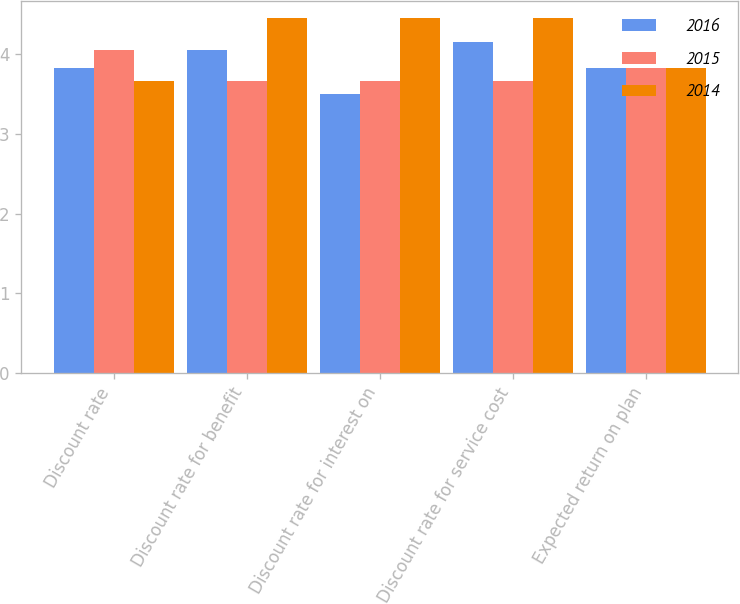Convert chart to OTSL. <chart><loc_0><loc_0><loc_500><loc_500><stacked_bar_chart><ecel><fcel>Discount rate<fcel>Discount rate for benefit<fcel>Discount rate for interest on<fcel>Discount rate for service cost<fcel>Expected return on plan<nl><fcel>2016<fcel>3.83<fcel>4.05<fcel>3.5<fcel>4.15<fcel>3.83<nl><fcel>2015<fcel>4.05<fcel>3.66<fcel>3.66<fcel>3.66<fcel>3.83<nl><fcel>2014<fcel>3.66<fcel>4.45<fcel>4.45<fcel>4.45<fcel>3.83<nl></chart> 